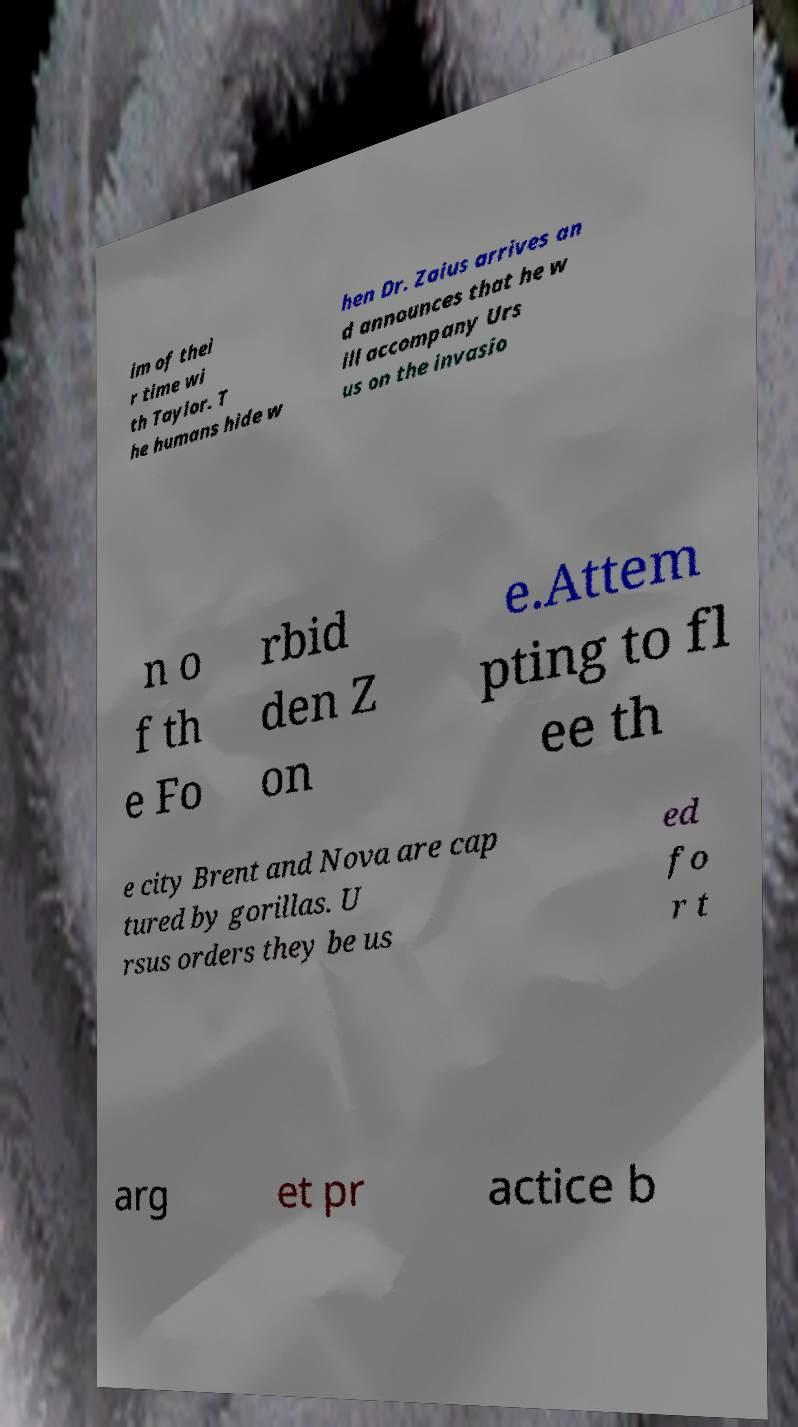Could you assist in decoding the text presented in this image and type it out clearly? im of thei r time wi th Taylor. T he humans hide w hen Dr. Zaius arrives an d announces that he w ill accompany Urs us on the invasio n o f th e Fo rbid den Z on e.Attem pting to fl ee th e city Brent and Nova are cap tured by gorillas. U rsus orders they be us ed fo r t arg et pr actice b 